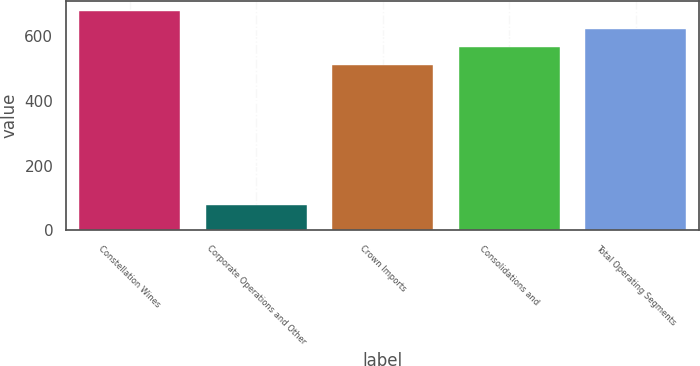Convert chart to OTSL. <chart><loc_0><loc_0><loc_500><loc_500><bar_chart><fcel>Constellation Wines<fcel>Corporate Operations and Other<fcel>Crown Imports<fcel>Consolidations and<fcel>Total Operating Segments<nl><fcel>674.42<fcel>79<fcel>509<fcel>564.14<fcel>619.28<nl></chart> 